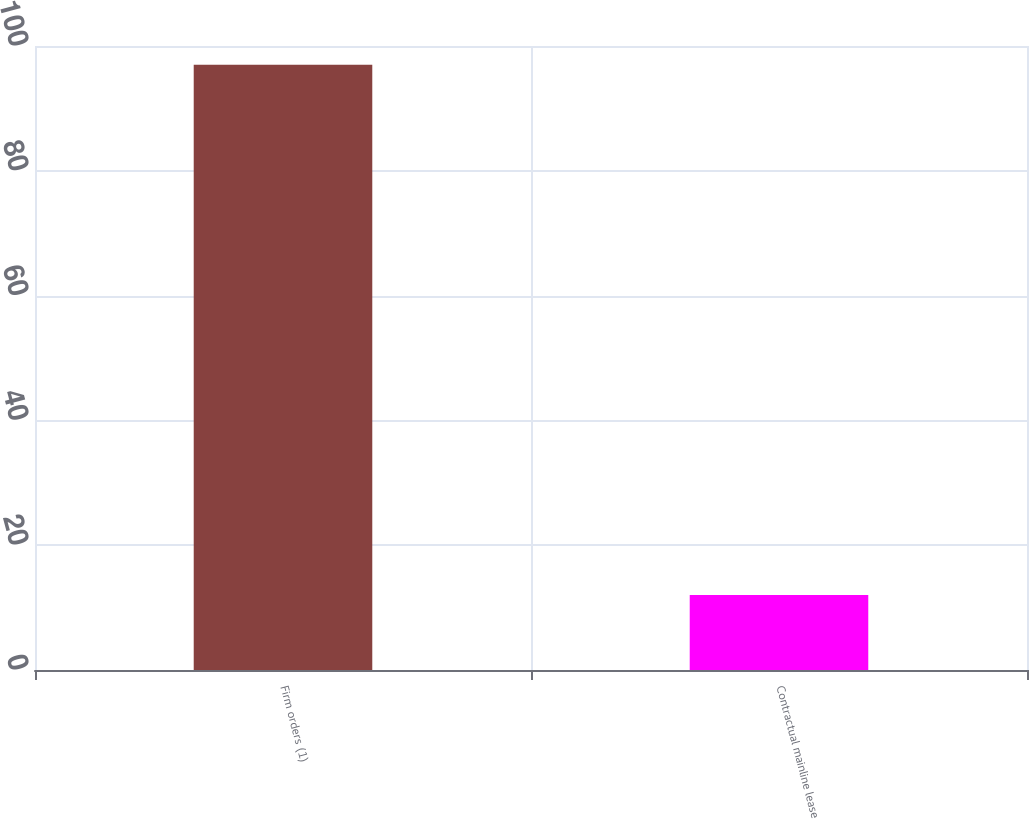Convert chart to OTSL. <chart><loc_0><loc_0><loc_500><loc_500><bar_chart><fcel>Firm orders (1)<fcel>Contractual mainline lease<nl><fcel>97<fcel>12<nl></chart> 